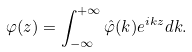Convert formula to latex. <formula><loc_0><loc_0><loc_500><loc_500>\varphi ( z ) = \int _ { - \infty } ^ { + \infty } \hat { \varphi } ( k ) e ^ { i k z } d k .</formula> 